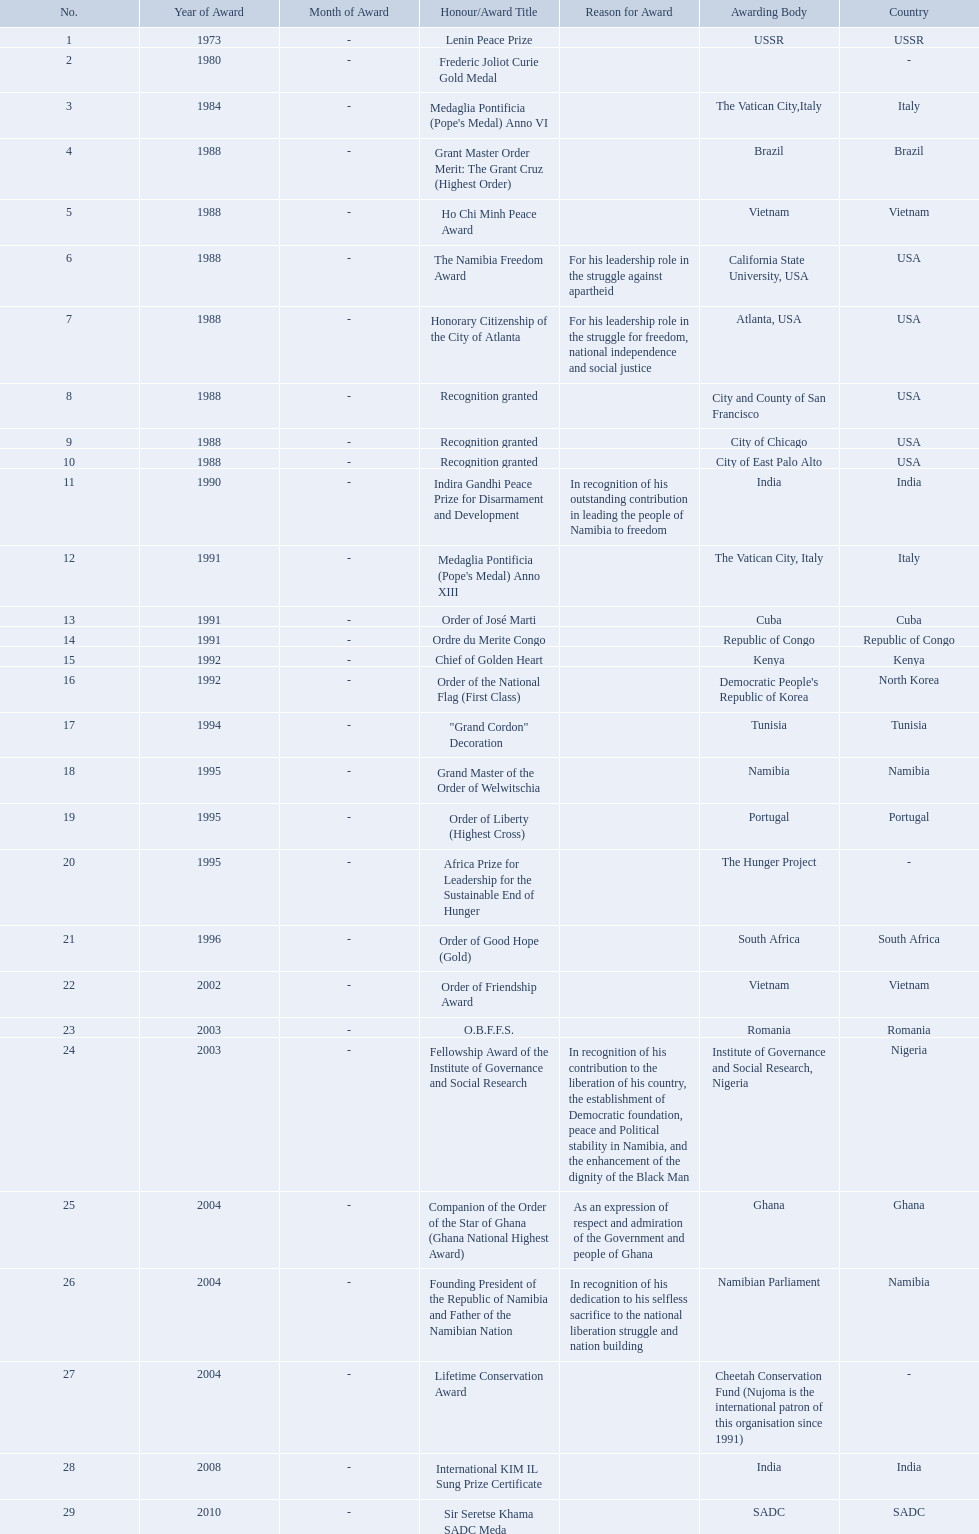What awards has sam nujoma been awarded? Lenin Peace Prize, Frederic Joliot Curie Gold Medal, Medaglia Pontificia (Pope's Medal) Anno VI, Grant Master Order Merit: The Grant Cruz (Highest Order), Ho Chi Minh Peace Award, The Namibia Freedom Award, Honorary Citizenship of the City of Atlanta, Recognition granted, Recognition granted, Recognition granted, Indira Gandhi Peace Prize for Disarmament and Development, Medaglia Pontificia (Pope's Medal) Anno XIII, Order of José Marti, Ordre du Merite Congo, Chief of Golden Heart, Order of the National Flag (First Class), "Grand Cordon" Decoration, Grand Master of the Order of Welwitschia, Order of Liberty (Highest Cross), Africa Prize for Leadership for the Sustainable End of Hunger, Order of Good Hope (Gold), Order of Friendship Award, O.B.F.F.S., Fellowship Award of the Institute of Governance and Social Research, Companion of the Order of the Star of Ghana (Ghana National Highest Award), Founding President of the Republic of Namibia and Father of the Namibian Nation, Lifetime Conservation Award, International KIM IL Sung Prize Certificate, Sir Seretse Khama SADC Meda. By which awarding body did sam nujoma receive the o.b.f.f.s award? Romania. Which awarding bodies have recognized sam nujoma? USSR, , The Vatican City,Italy, Brazil, Vietnam, California State University, USA, Atlanta, USA, City and County of San Francisco, City of Chicago, City of East Palo Alto, India, The Vatican City, Italy, Cuba, Republic of Congo, Kenya, Democratic People's Republic of Korea, Tunisia, Namibia, Portugal, The Hunger Project, South Africa, Vietnam, Romania, Institute of Governance and Social Research, Nigeria, Ghana, Namibian Parliament, Cheetah Conservation Fund (Nujoma is the international patron of this organisation since 1991), India, SADC. And what was the title of each award or honour? Lenin Peace Prize, Frederic Joliot Curie Gold Medal, Medaglia Pontificia (Pope's Medal) Anno VI, Grant Master Order Merit: The Grant Cruz (Highest Order), Ho Chi Minh Peace Award, The Namibia Freedom Award, Honorary Citizenship of the City of Atlanta, Recognition granted, Recognition granted, Recognition granted, Indira Gandhi Peace Prize for Disarmament and Development, Medaglia Pontificia (Pope's Medal) Anno XIII, Order of José Marti, Ordre du Merite Congo, Chief of Golden Heart, Order of the National Flag (First Class), "Grand Cordon" Decoration, Grand Master of the Order of Welwitschia, Order of Liberty (Highest Cross), Africa Prize for Leadership for the Sustainable End of Hunger, Order of Good Hope (Gold), Order of Friendship Award, O.B.F.F.S., Fellowship Award of the Institute of Governance and Social Research, Companion of the Order of the Star of Ghana (Ghana National Highest Award), Founding President of the Republic of Namibia and Father of the Namibian Nation, Lifetime Conservation Award, International KIM IL Sung Prize Certificate, Sir Seretse Khama SADC Meda. Of those, which nation awarded him the o.b.f.f.s.? Romania. What awards did sam nujoma win? 1, 1973, Lenin Peace Prize, Frederic Joliot Curie Gold Medal, Medaglia Pontificia (Pope's Medal) Anno VI, Grant Master Order Merit: The Grant Cruz (Highest Order), Ho Chi Minh Peace Award, The Namibia Freedom Award, Honorary Citizenship of the City of Atlanta, Recognition granted, Recognition granted, Recognition granted, Indira Gandhi Peace Prize for Disarmament and Development, Medaglia Pontificia (Pope's Medal) Anno XIII, Order of José Marti, Ordre du Merite Congo, Chief of Golden Heart, Order of the National Flag (First Class), "Grand Cordon" Decoration, Grand Master of the Order of Welwitschia, Order of Liberty (Highest Cross), Africa Prize for Leadership for the Sustainable End of Hunger, Order of Good Hope (Gold), Order of Friendship Award, O.B.F.F.S., Fellowship Award of the Institute of Governance and Social Research, Companion of the Order of the Star of Ghana (Ghana National Highest Award), Founding President of the Republic of Namibia and Father of the Namibian Nation, Lifetime Conservation Award, International KIM IL Sung Prize Certificate, Sir Seretse Khama SADC Meda. Who was the awarding body for the o.b.f.f.s award? Romania. 